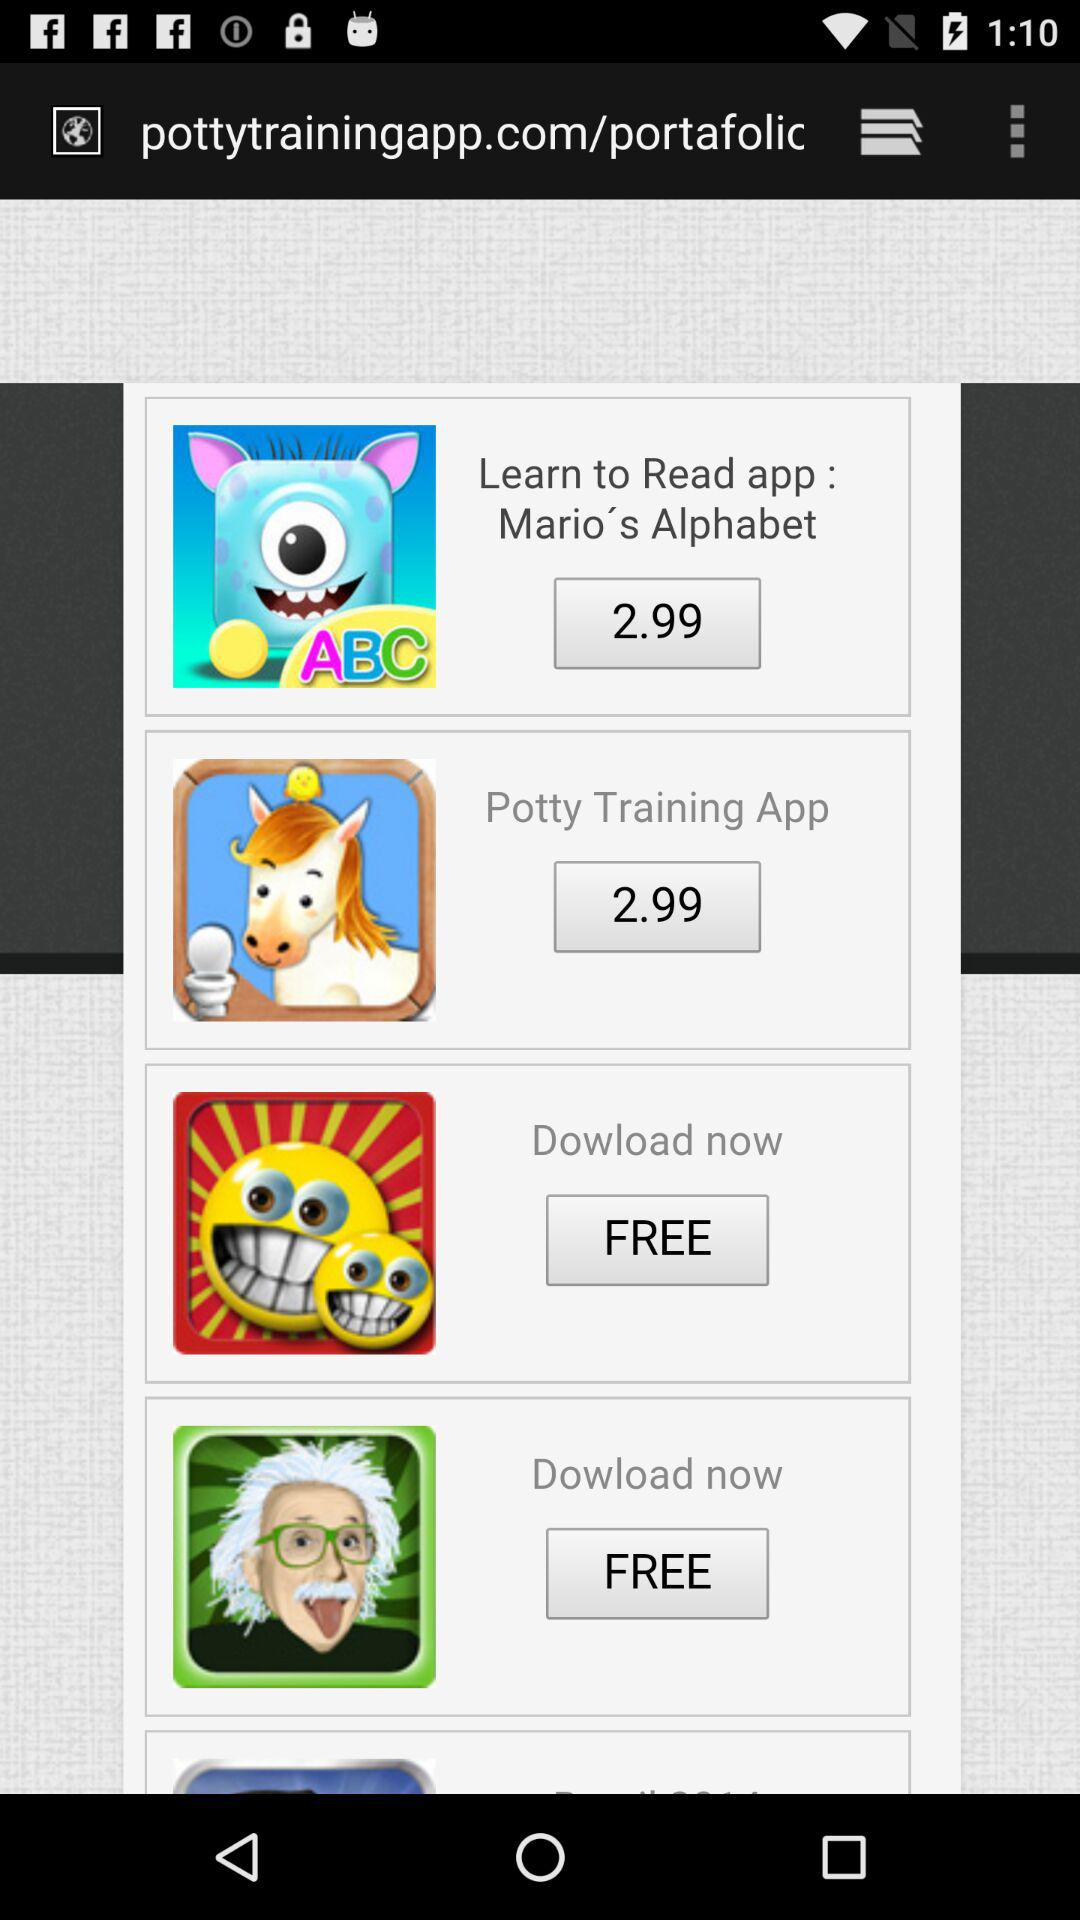What is the price of the "Learn to Read app : Mario's Alphabet"? The price is 2.99. 